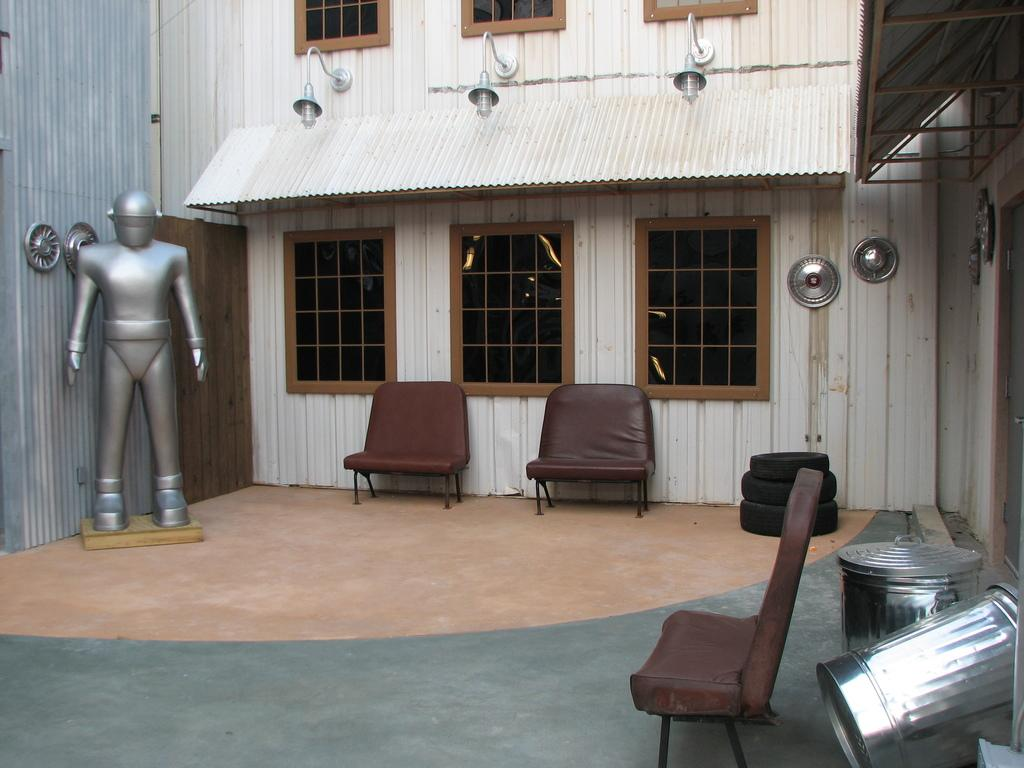What type of furniture can be found in the room? There are chairs in the room. What kind of decoration is present in the room? There is a statue of a person in the room. What allows natural light to enter the room? There are windows in the room. What provides illumination in the room? There are lights in the room. What covers the top of the room? There is a roof in the room. What type of objects are made of rubber and can be found in the room? There are tyres in the room. What type of fruit is hanging from the statue in the room? There is no fruit present in the image, and the statue does not have any fruit hanging from it. What type of stove is used for cooking in the room? There is no stove present in the room. 